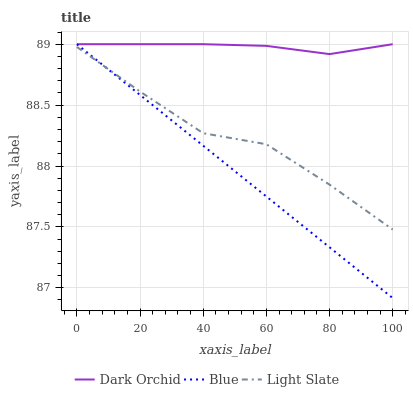Does Blue have the minimum area under the curve?
Answer yes or no. Yes. Does Dark Orchid have the maximum area under the curve?
Answer yes or no. Yes. Does Light Slate have the minimum area under the curve?
Answer yes or no. No. Does Light Slate have the maximum area under the curve?
Answer yes or no. No. Is Blue the smoothest?
Answer yes or no. Yes. Is Light Slate the roughest?
Answer yes or no. Yes. Is Dark Orchid the smoothest?
Answer yes or no. No. Is Dark Orchid the roughest?
Answer yes or no. No. Does Blue have the lowest value?
Answer yes or no. Yes. Does Light Slate have the lowest value?
Answer yes or no. No. Does Dark Orchid have the highest value?
Answer yes or no. Yes. Does Light Slate have the highest value?
Answer yes or no. No. Is Light Slate less than Dark Orchid?
Answer yes or no. Yes. Is Dark Orchid greater than Light Slate?
Answer yes or no. Yes. Does Dark Orchid intersect Blue?
Answer yes or no. Yes. Is Dark Orchid less than Blue?
Answer yes or no. No. Is Dark Orchid greater than Blue?
Answer yes or no. No. Does Light Slate intersect Dark Orchid?
Answer yes or no. No. 